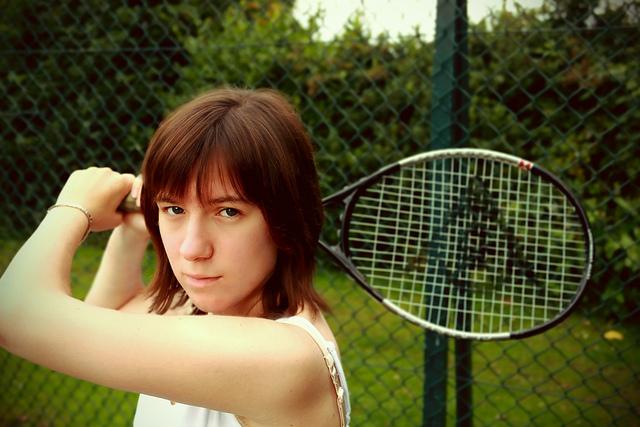What brand name is on this tennis racket?
Be succinct. Wilson. What kind of fence is in the picture?
Write a very short answer. Chain link. Is she playing golf?
Give a very brief answer. No. 